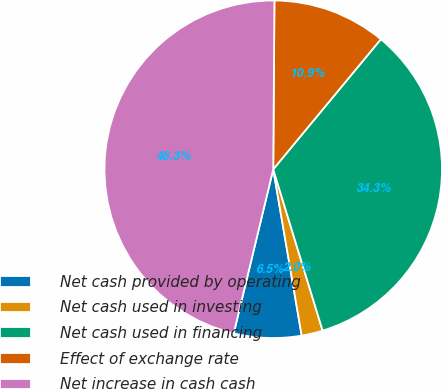<chart> <loc_0><loc_0><loc_500><loc_500><pie_chart><fcel>Net cash provided by operating<fcel>Net cash used in investing<fcel>Net cash used in financing<fcel>Effect of exchange rate<fcel>Net increase in cash cash<nl><fcel>6.46%<fcel>2.03%<fcel>34.27%<fcel>10.89%<fcel>46.35%<nl></chart> 